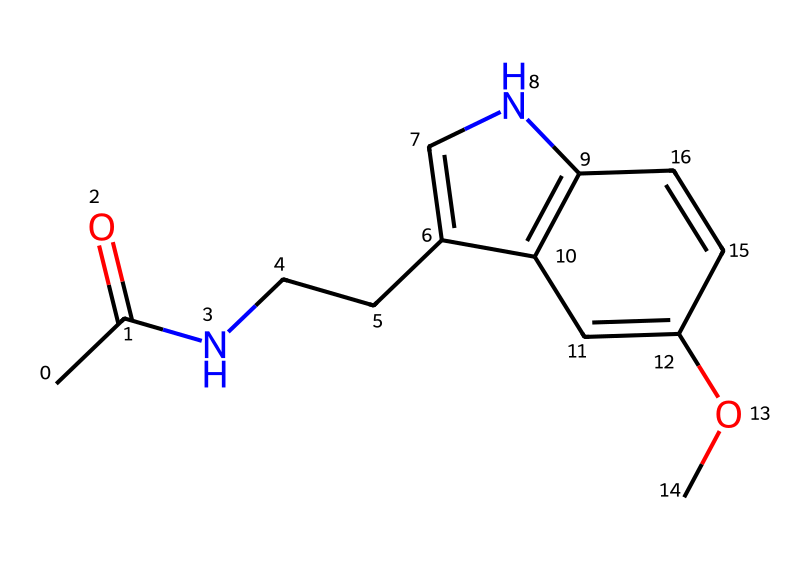What is the main functional group present in this molecule? The presence of the carbonyl group (C=O) attached to a nitrogen atom indicates that this molecule contains an amide functional group, characteristic of melatonin.
Answer: amide How many rings are present in the molecular structure? By analyzing the cyclic portions in the SMILES representation, one can count two distinct ring structures; hence, the molecule contains two rings.
Answer: two What is the total number of carbon atoms in the structure? Counting the carbon elements present in the SMILES representation reveals a total of 13 carbon atoms in the entire molecule.
Answer: 13 What element is represented by the 'N' in the structure? The 'N' denotes the presence of nitrogen, which in this context is part of the amide functional group contributing to the molecule’s properties.
Answer: nitrogen Which substituent is visible in the molecule that is indicative of a methoxy group? The presence of the '-O-' connected to a carbon indicates a methoxy group, as it links an oxygen atom with a methyl group (–OCH3).
Answer: methoxy What property does the combination of rings and nitrogen confer to the molecule? The cyclic structure and nitrogen inclusion yield the chemical its biological activity, particularly influencing sleep regulation as seen in melatonin.
Answer: biological activity 